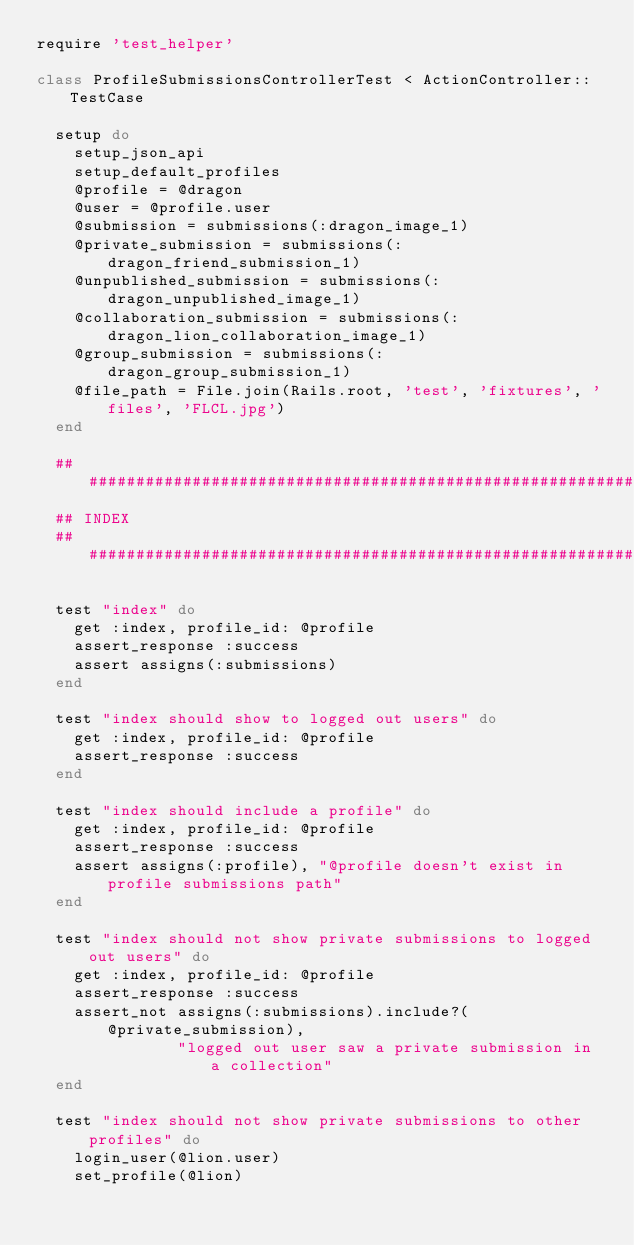<code> <loc_0><loc_0><loc_500><loc_500><_Ruby_>require 'test_helper'

class ProfileSubmissionsControllerTest < ActionController::TestCase

  setup do
    setup_json_api
    setup_default_profiles
    @profile = @dragon
    @user = @profile.user
    @submission = submissions(:dragon_image_1)
    @private_submission = submissions(:dragon_friend_submission_1)
    @unpublished_submission = submissions(:dragon_unpublished_image_1)
    @collaboration_submission = submissions(:dragon_lion_collaboration_image_1)
    @group_submission = submissions(:dragon_group_submission_1)
    @file_path = File.join(Rails.root, 'test', 'fixtures', 'files', 'FLCL.jpg')
  end

  ###################################################################
  ## INDEX
  ###################################################################

  test "index" do
    get :index, profile_id: @profile
    assert_response :success
    assert assigns(:submissions)
  end

  test "index should show to logged out users" do
    get :index, profile_id: @profile
    assert_response :success
  end

  test "index should include a profile" do
    get :index, profile_id: @profile
    assert_response :success
    assert assigns(:profile), "@profile doesn't exist in profile submissions path"
  end

  test "index should not show private submissions to logged out users" do
    get :index, profile_id: @profile
    assert_response :success
    assert_not assigns(:submissions).include?(@private_submission),
               "logged out user saw a private submission in a collection"
  end

  test "index should not show private submissions to other profiles" do
    login_user(@lion.user)
    set_profile(@lion)</code> 